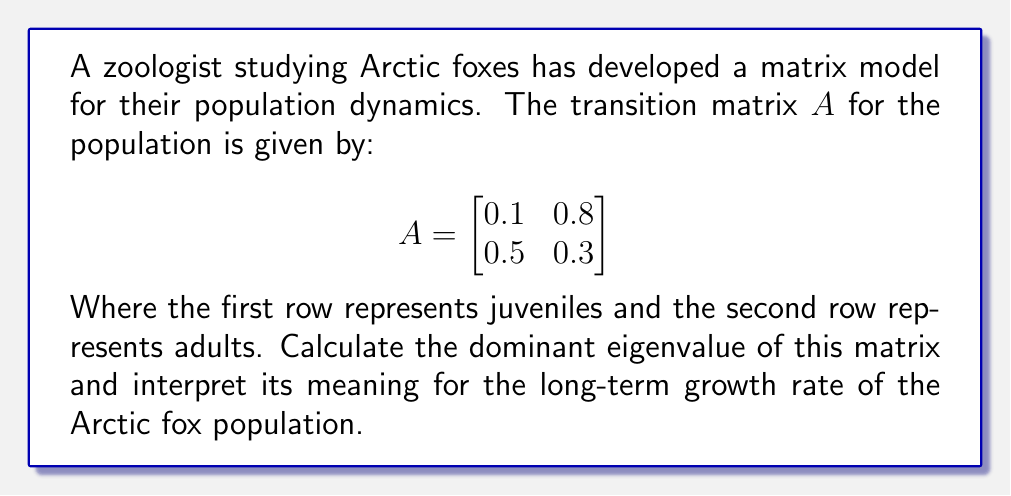Teach me how to tackle this problem. To find the dominant eigenvalue and interpret its meaning for the Arctic fox population:

1) First, we need to find the eigenvalues of matrix $A$. The characteristic equation is:

   $det(A - \lambda I) = 0$

   $$\begin{vmatrix}
   0.1 - \lambda & 0.8 \\
   0.5 & 0.3 - \lambda
   \end{vmatrix} = 0$$

2) Expanding the determinant:

   $(0.1 - \lambda)(0.3 - \lambda) - 0.4 = 0$
   
   $\lambda^2 - 0.4\lambda - 0.37 = 0$

3) Solving this quadratic equation:

   $\lambda = \frac{0.4 \pm \sqrt{0.16 + 1.48}}{2} = \frac{0.4 \pm \sqrt{1.64}}{2} = \frac{0.4 \pm 1.28}{2}$

4) This gives us two eigenvalues:

   $\lambda_1 = \frac{0.4 + 1.28}{2} = 0.84$
   $\lambda_2 = \frac{0.4 - 1.28}{2} = -0.44$

5) The dominant eigenvalue is the larger one in absolute value: $\lambda_1 = 0.84$

6) Interpretation: In population dynamics, the dominant eigenvalue represents the long-term growth rate of the population. Since $0.84 < 1$, this indicates that the Arctic fox population is decreasing over time. Specifically, the population will decrease by about 16% (1 - 0.84 = 0.16) in each time step.
Answer: $\lambda_1 = 0.84$; population decreasing by ~16% each time step 